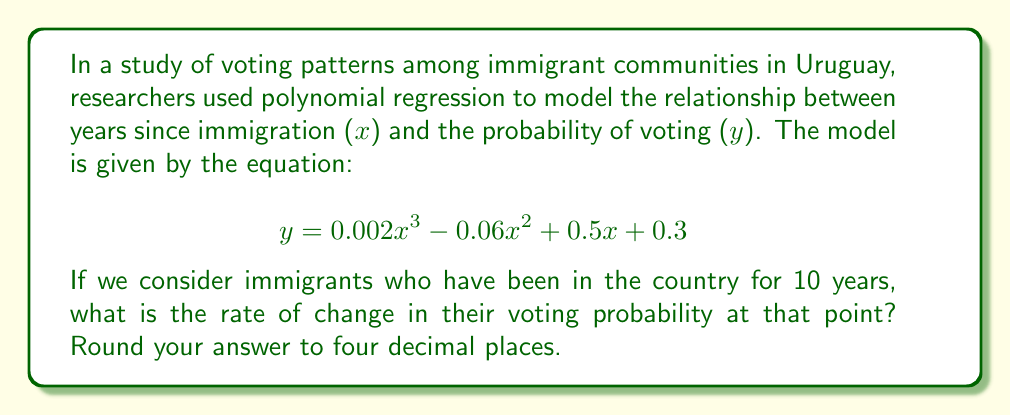Teach me how to tackle this problem. To find the rate of change in the voting probability after 10 years, we need to calculate the derivative of the given polynomial function and evaluate it at x = 10.

Step 1: Find the derivative of the function.
$$ \frac{dy}{dx} = 0.002 \cdot 3x^2 - 0.06 \cdot 2x + 0.5 $$
$$ \frac{dy}{dx} = 0.006x^2 - 0.12x + 0.5 $$

Step 2: Evaluate the derivative at x = 10.
$$ \frac{dy}{dx}\bigg|_{x=10} = 0.006(10)^2 - 0.12(10) + 0.5 $$
$$ = 0.006(100) - 1.2 + 0.5 $$
$$ = 0.6 - 1.2 + 0.5 $$
$$ = -0.1 $$

Step 3: Round the result to four decimal places.
$$ -0.1000 $$

Therefore, the rate of change in voting probability for immigrants who have been in the country for 10 years is -0.1000 or -10% per year.
Answer: -0.1000 